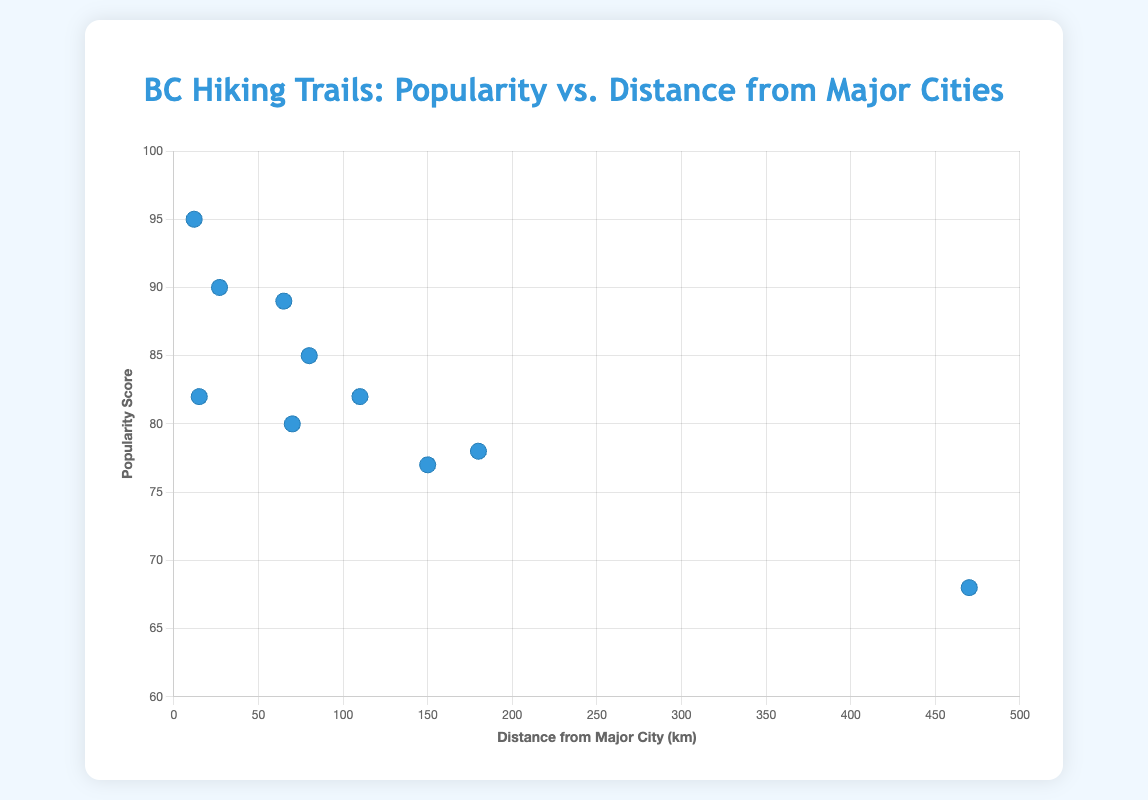what's the title of the scatter plot? The title is written at the top center of the figure and is "BC Hiking Trails: Popularity vs. Distance from Major Cities."
Answer: BC Hiking Trails: Popularity vs. Distance from Major Cities what is the distance and popularity score of the most distant hiking trail? The most distant hiking trail is represented by the point farthest to the right on the x-axis. It belongs to "Cape Scott Trail" which is 470 km from a major city with a popularity score of 68.
Answer: 470 km and 68 how many hiking trails are displayed in the scatter plot? Counting each data point (each dot) in the scatter plot gives a total of 10 hiking trails displayed.
Answer: 10 what's the popularity score of "Grouse Grind"? By locating the data point labeled "Grouse Grind" (x: 12, y: 95), the corresponding y-value reflects the popularity score.
Answer: 95 which trail has the highest popularity score? By finding the highest point on the y-axis, "Grouse Grind" has the highest popularity score at 95.
Answer: Grouse Grind what is the average distance of trails from major cities? To find the average distance, sum all distances (12 + 65 + 80 + 180 + 15 + 150 + 70 + 110 + 470 + 27) = 1179 km, then divide by the number of trails (10). The average distance is 1179/10 = 117.9 km.
Answer: 117.9 km which trail has a higher popularity score, "Joffre Lakes Trail" or "Juan de Fuca Trail"? Locate the points for both trails and compare their y-values. "Joffre Lakes Trail" has a popularity score of 78, whereas "Juan de Fuca Trail" has a score of 77. Hence, "Joffre Lakes Trail" has a higher score.
Answer: Joffre Lakes Trail how far is "Lynn Loop" from its major city and what is its popularity score? Locate the data point labeled "Lynn Loop" (x: 15, y: 82), the x-value represents the distance and the y-value represents the popularity score.
Answer: 15 km and 82 what's the range of popularity scores among the trails? The range is the difference between the highest and lowest popularity scores. The highest score is 95 (Grouse Grind) and the lowest is 68 (Cape Scott Trail), thus the range is 95 - 68 = 27.
Answer: 27 how does the popularity score of "Elfin Lakes" compare to that of "Black Tusk"? The data points for "Elfin Lakes" and "Black Tusk" show popularity scores of 80 and 82, respectively. Therefore, "Black Tusk" is more popular.
Answer: Black Tusk 